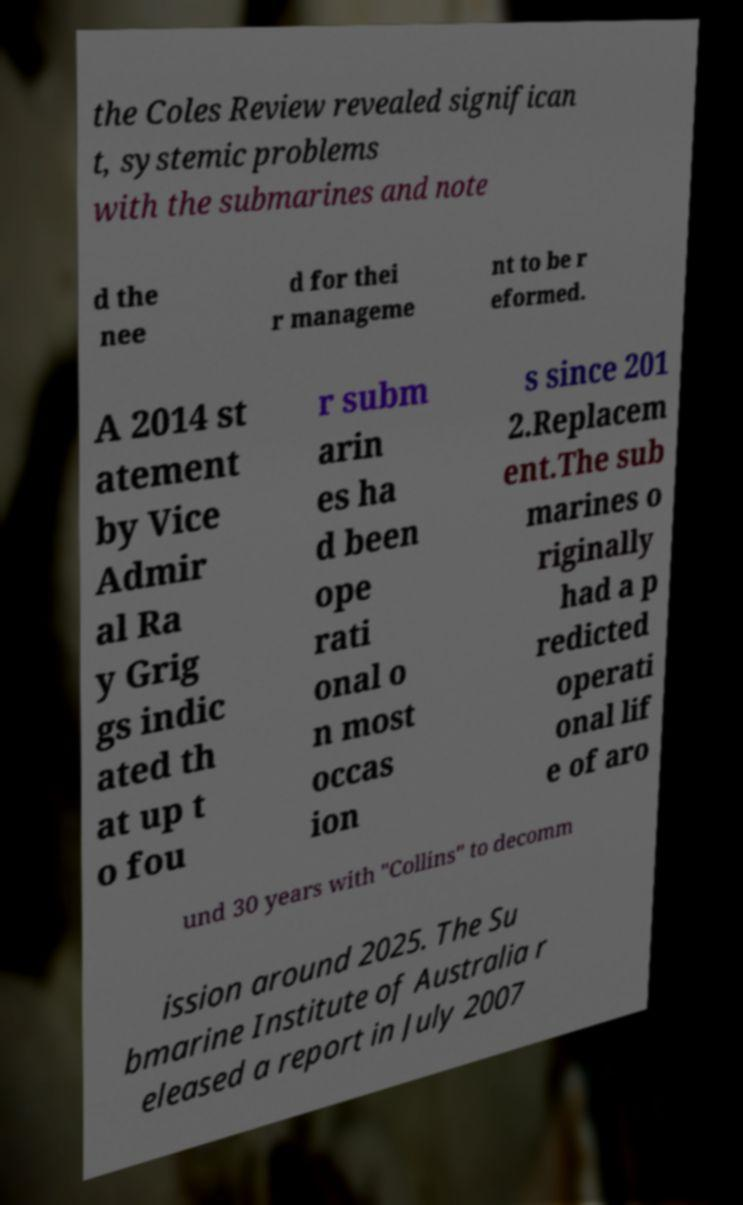Could you extract and type out the text from this image? the Coles Review revealed significan t, systemic problems with the submarines and note d the nee d for thei r manageme nt to be r eformed. A 2014 st atement by Vice Admir al Ra y Grig gs indic ated th at up t o fou r subm arin es ha d been ope rati onal o n most occas ion s since 201 2.Replacem ent.The sub marines o riginally had a p redicted operati onal lif e of aro und 30 years with "Collins" to decomm ission around 2025. The Su bmarine Institute of Australia r eleased a report in July 2007 